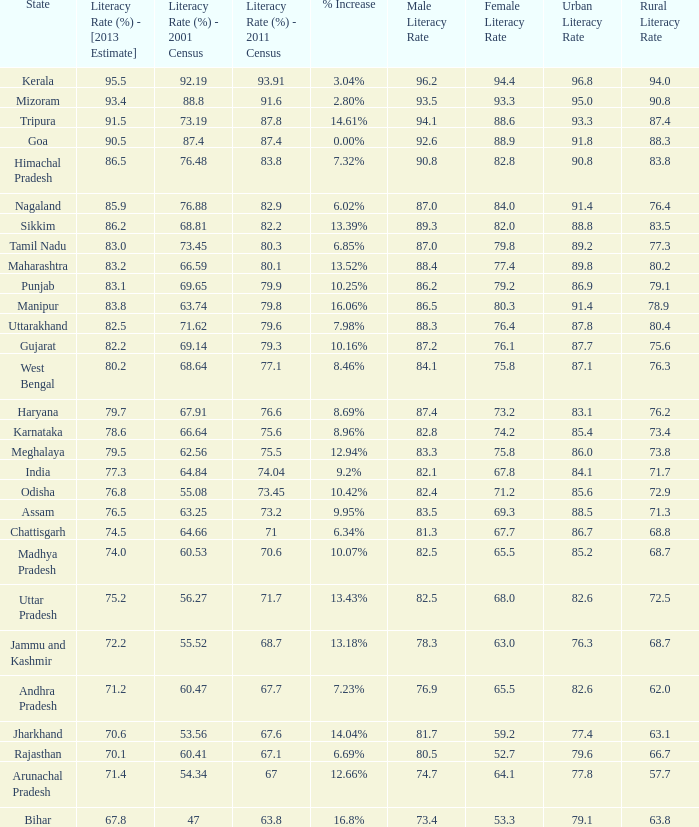What is the average increase in literacy for the states that had a rate higher than 73.2% in 2011, less than 68.81% in 2001, and an estimate of 76.8% for 2013? 10.42%. 